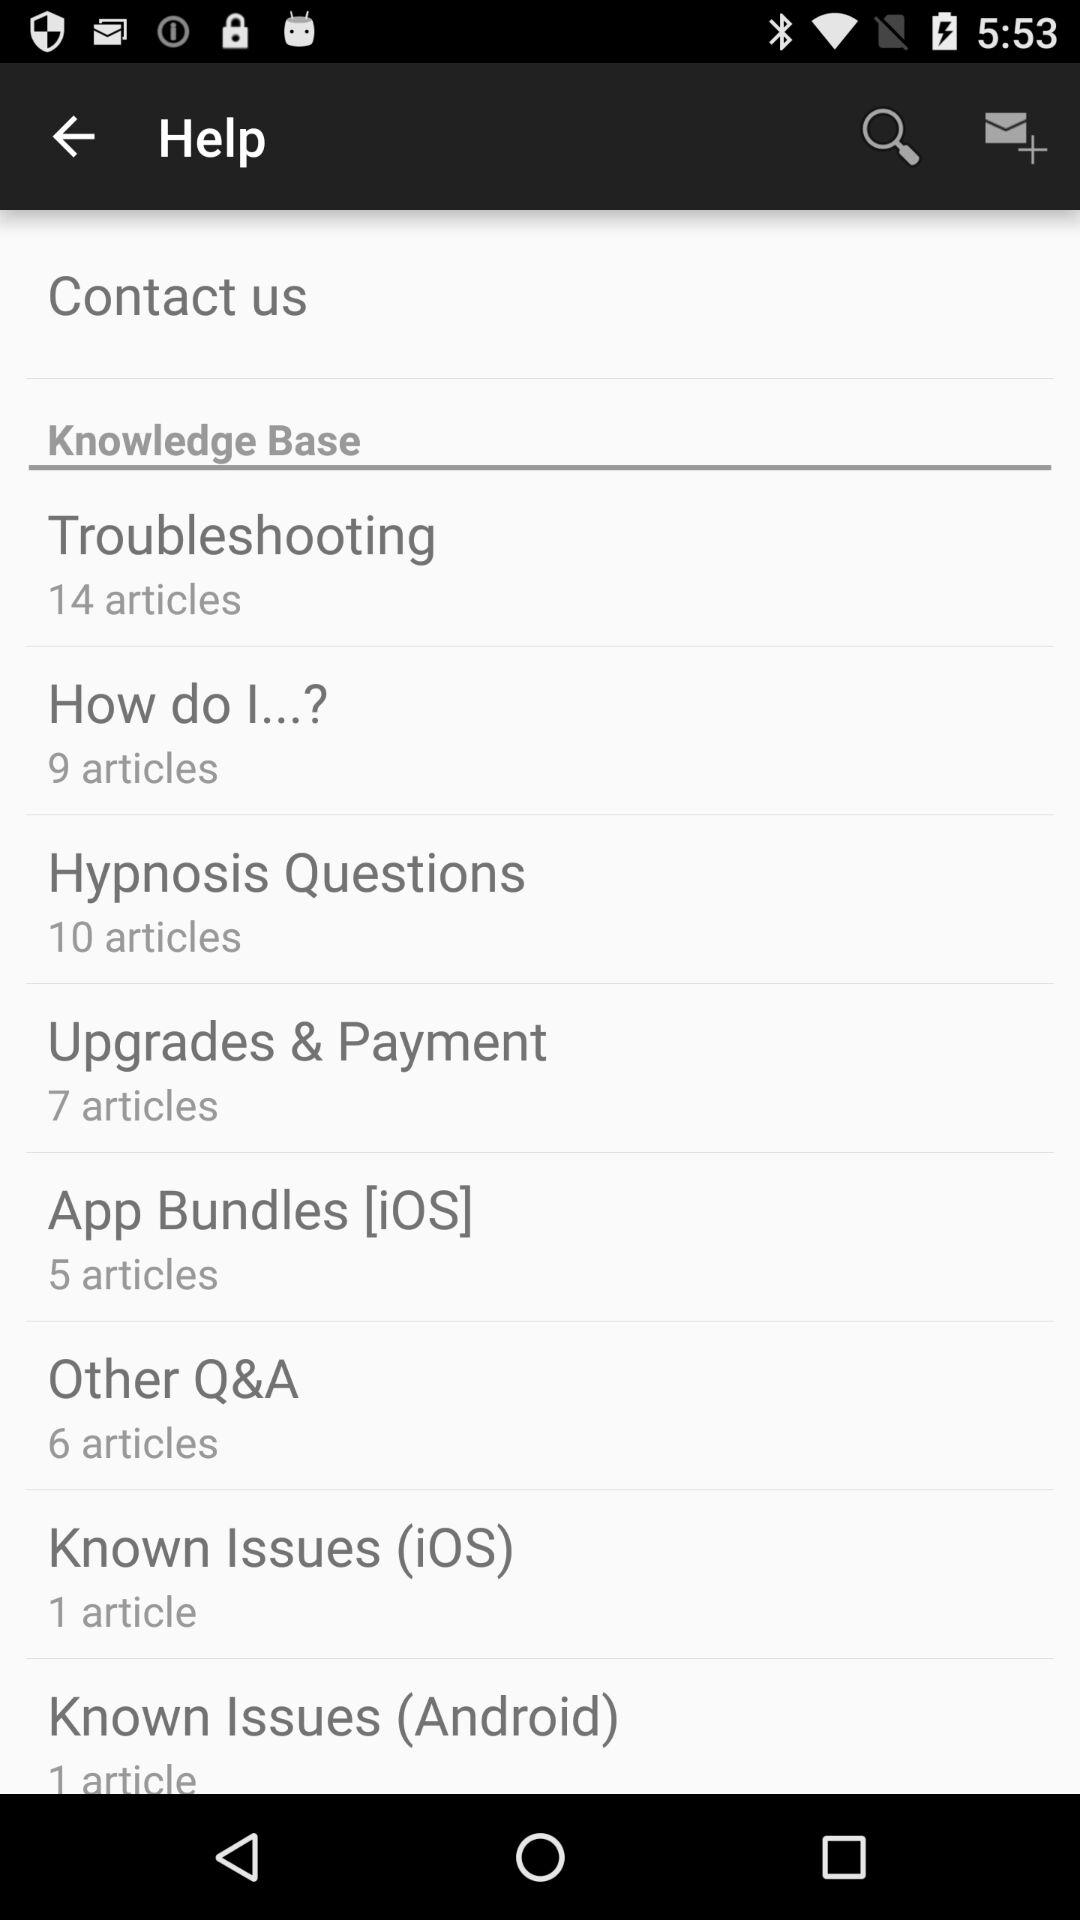How many articles are there in "Hypnosis Questions"? There are 10 articles in "Hypnosis Questions". 